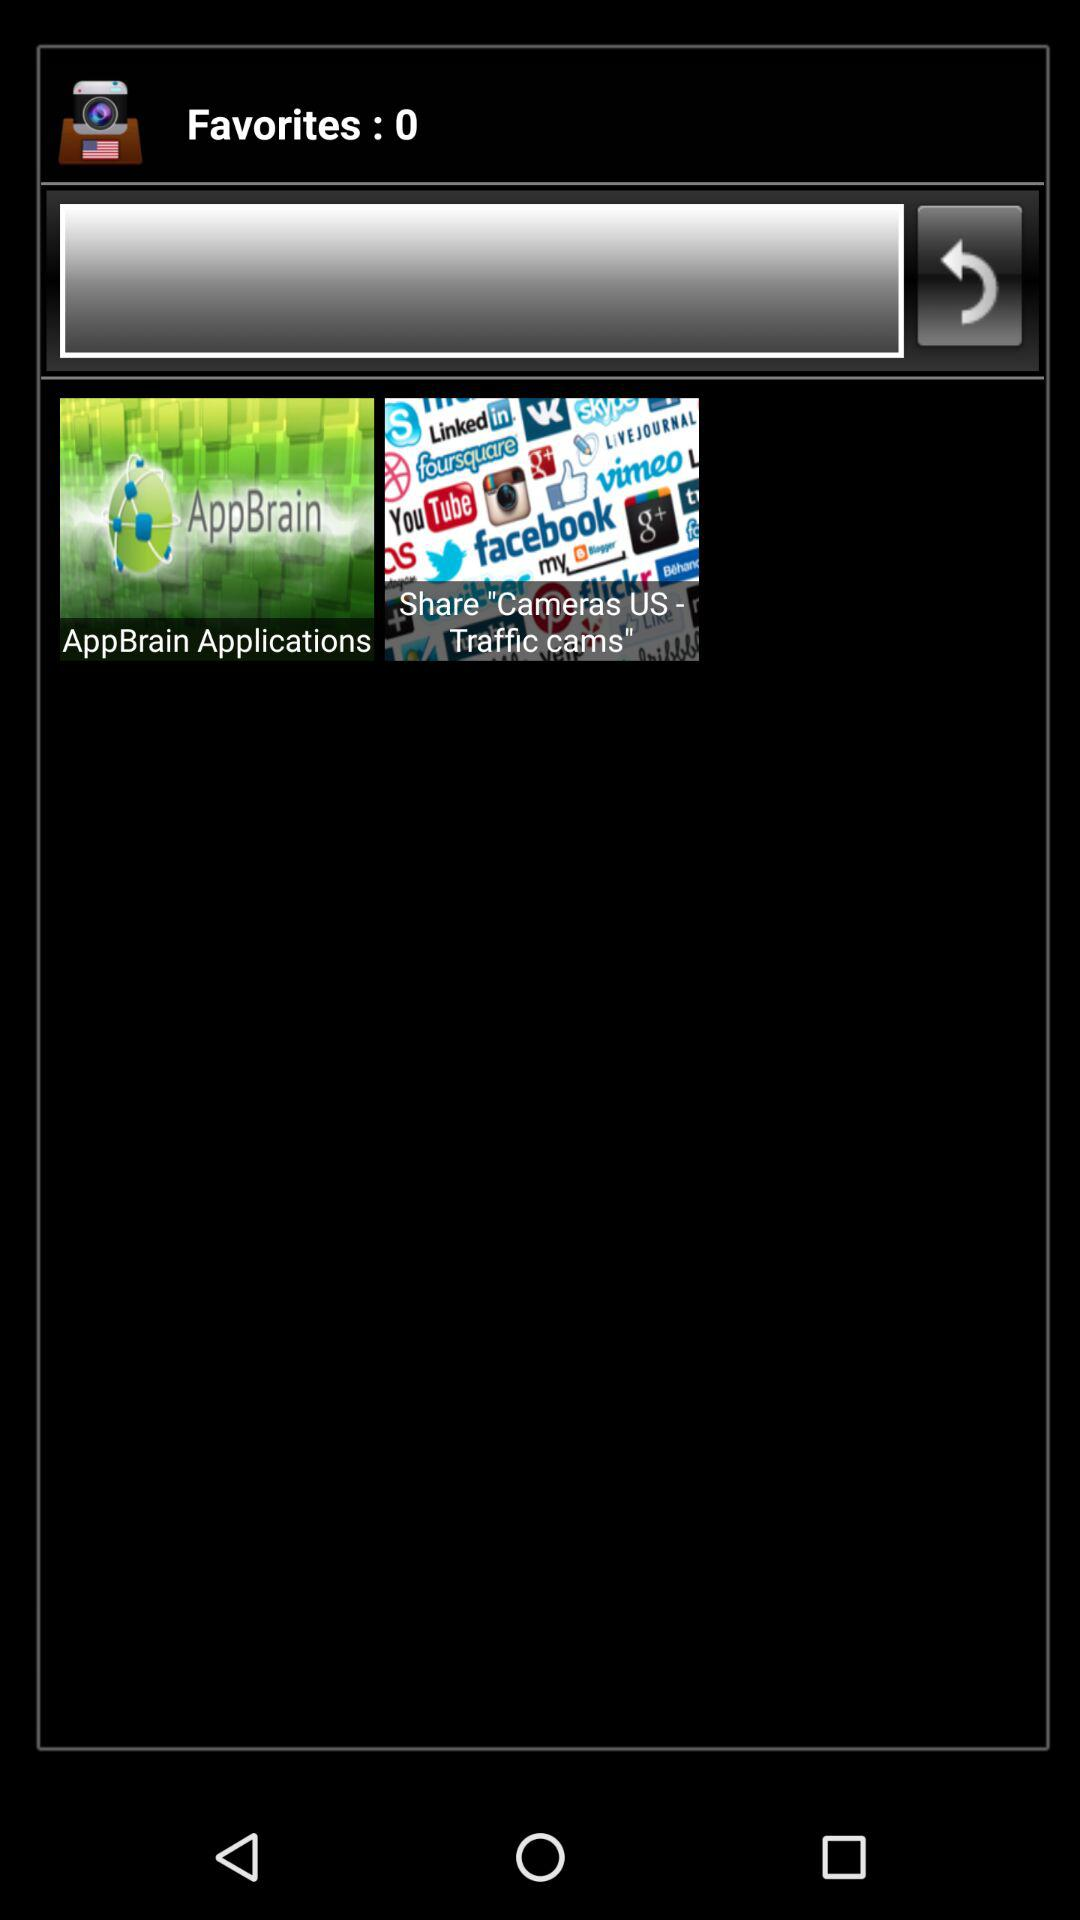How many total favourites are there? There are 0 favorites. 